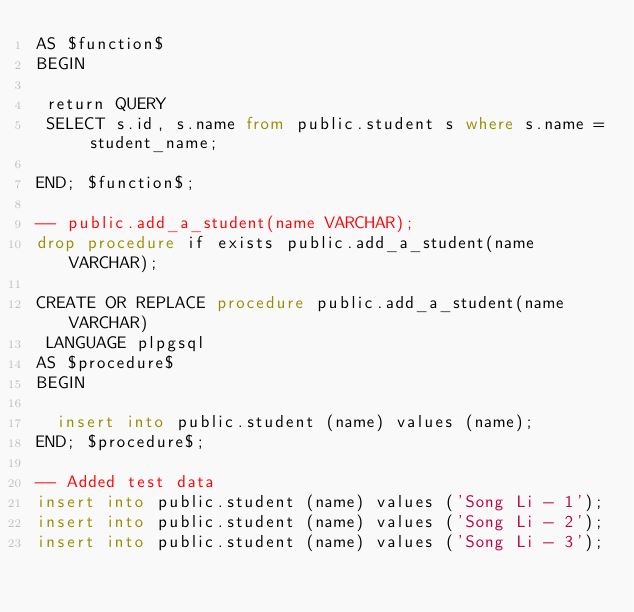Convert code to text. <code><loc_0><loc_0><loc_500><loc_500><_SQL_>AS $function$
BEGIN
 
 return QUERY
 SELECT s.id, s.name from public.student s where s.name = student_name;

END; $function$;

-- public.add_a_student(name VARCHAR);
drop procedure if exists public.add_a_student(name VARCHAR);

CREATE OR REPLACE procedure public.add_a_student(name VARCHAR)
 LANGUAGE plpgsql
AS $procedure$
BEGIN

	insert into public.student (name) values (name);	
END; $procedure$;

-- Added test data
insert into public.student (name) values ('Song Li - 1');
insert into public.student (name) values ('Song Li - 2');
insert into public.student (name) values ('Song Li - 3');

</code> 